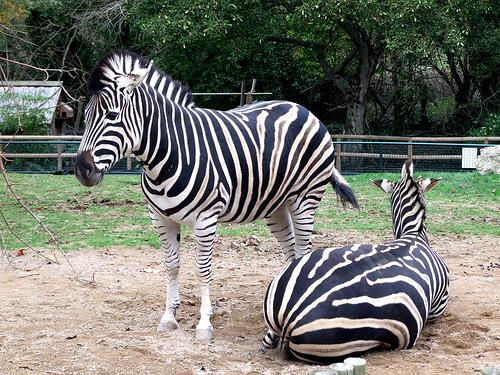Perform a complex reasoning task by identifying the relationship between a zebra's black stripes and their standing or laying down position. There is no direct relationship between a zebra's black stripes and their standing or laying down position; it is each zebra's individual choice to stand or lay down, regardless of their stripe pattern. What is the main animal present in the image and what are its prominent features? The main animal is a zebra with black stripes, white and black mane, and a black nose and mouth. From the image, determine how many zebras are present and whether they are standing or laying. There are two zebras, one standing and one laying down. What is the sentiment conveyed by the image of the two zebras? The sentiment conveyed is one of peaceful coexistence and companionship. Count the number of black stripes present on the standing zebra. There are 15 black stripes present on the standing zebra. In a poetic manner, describe the setting of the image. Beside the tree with green leaves, there lies a duet of zebras on a canvas of dirt and grass, with a fence and building nestled in the distance. Identify the different objects in the image and the interactions between them. Objects in the image include two zebras, a tree, grass, a fence, and a shed. The zebras are interacting by standing and laying down next to each other. Analyzing the image, evaluate the quality of the environment where the zebras are situated. The environment is of moderate quality with dirt ground, green grass, trees, a fence, and a building in the background, which seems natural but also potentially affected by human intervention. In the form of a story, explain what you see taking place between the two zebras in the image. Once upon a time, on a dirt ground surrounded by grass and trees, a resting zebra lay beside its friend who stood watch. The standing zebra, looking straight ahead, guarded the sleeping beauty from any potential danger lurking behind the fence. 